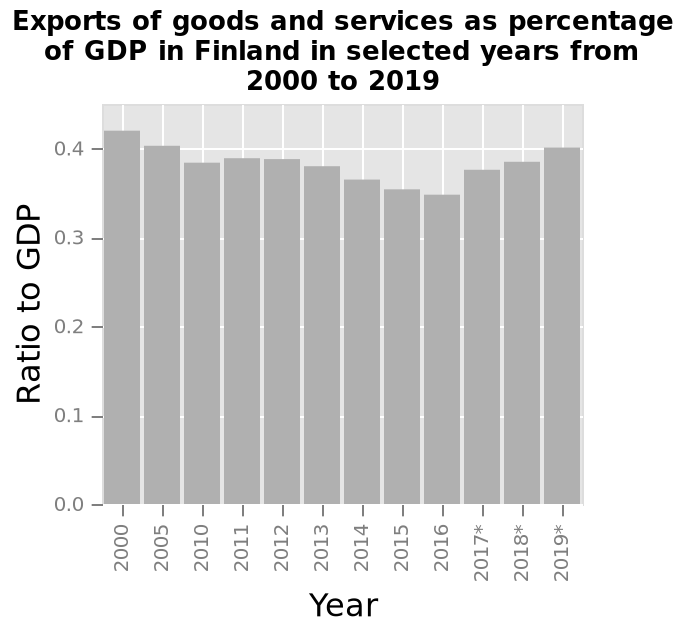<image>
What was the ratio of goods and services as a percentage of GDP in 2017? The description does not mention the exact ratio of goods and services as a percentage of GDP in 2017. What is shown on the x-axis of the bar plot? The x-axis of the bar plot shows the "Year" along a categorical scale starting with 2000 and ending with 2019. 